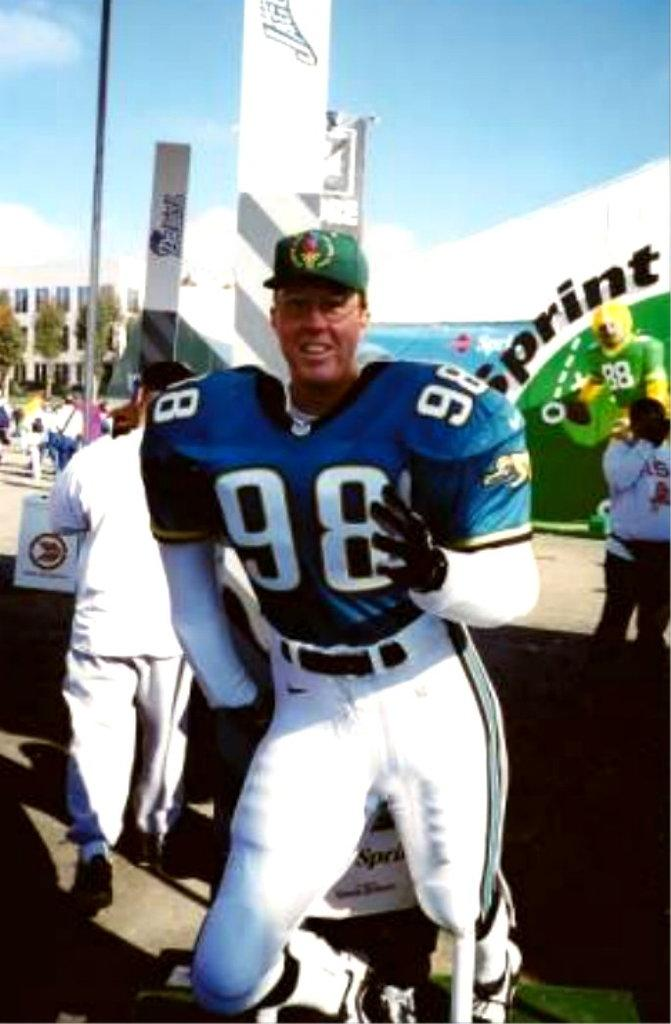<image>
Offer a succinct explanation of the picture presented. the player in the front is wearing a number 98 jersey 